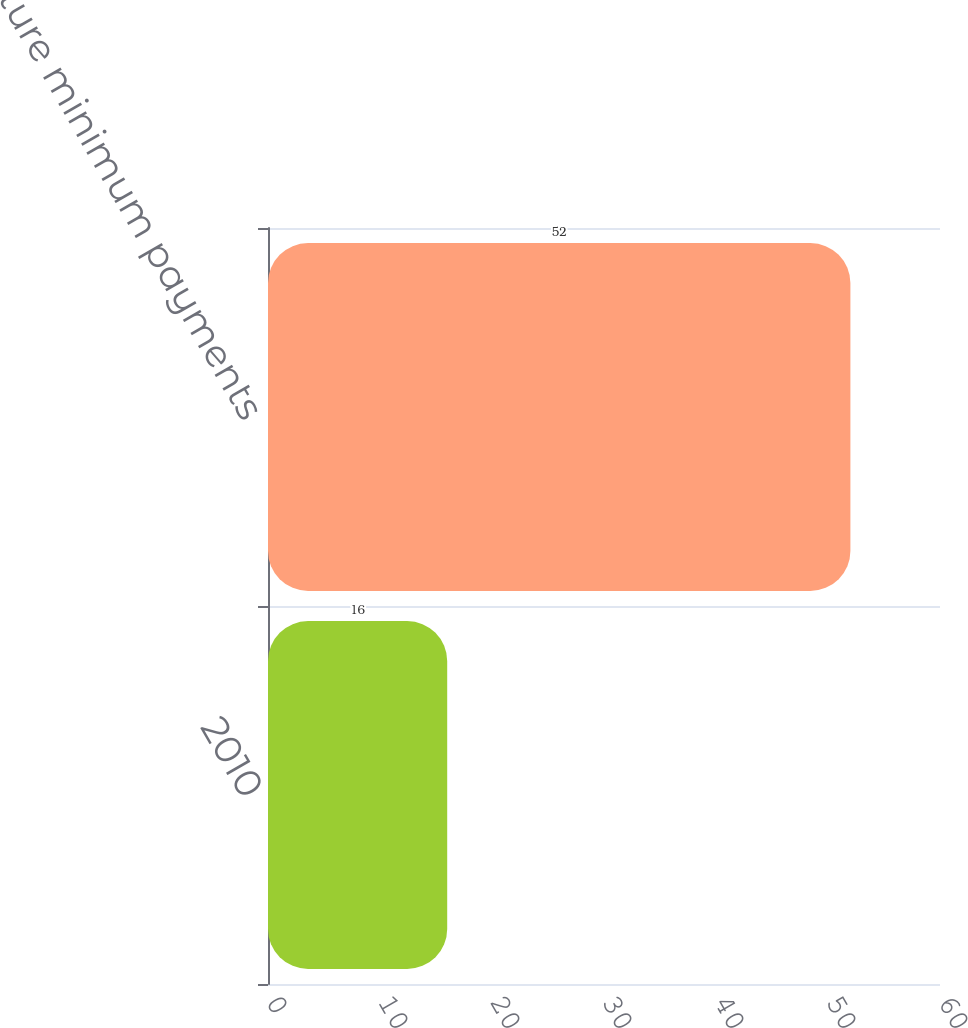Convert chart to OTSL. <chart><loc_0><loc_0><loc_500><loc_500><bar_chart><fcel>2010<fcel>Total future minimum payments<nl><fcel>16<fcel>52<nl></chart> 